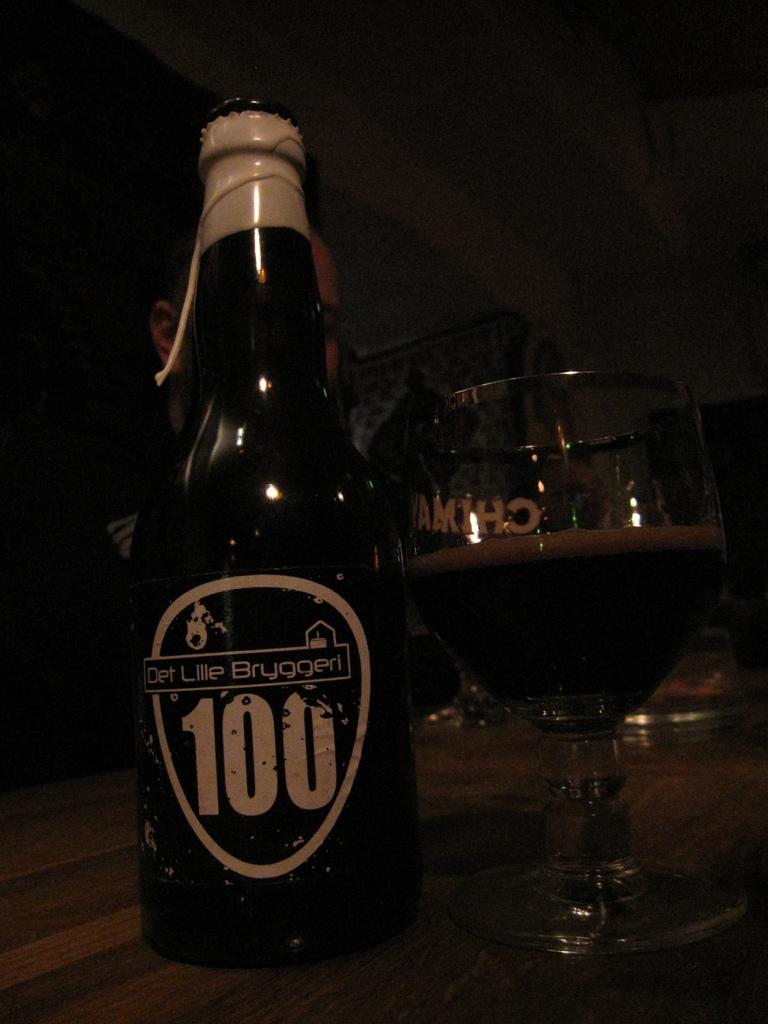<image>
Render a clear and concise summary of the photo. Det Lillie Bruggeri is the maker of the bottled beverage. 